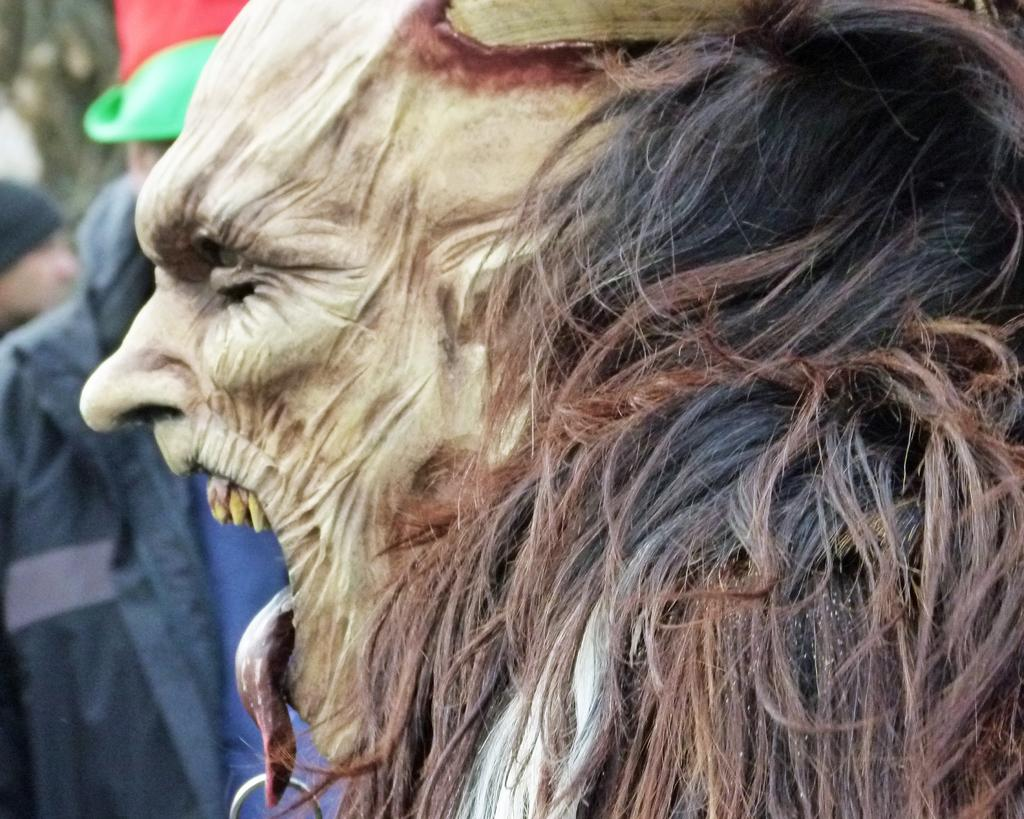What is the person in the image wearing on their face? The person in the image is wearing a mask. What is on the person's tongue in the image? There is an object on the person's tongue in the image. Can you describe the other person visible in the background of the image? There is another person visible in the background of the image. How many dimes are visible on the sheet in the image? There is no sheet or dimes present in the image. 